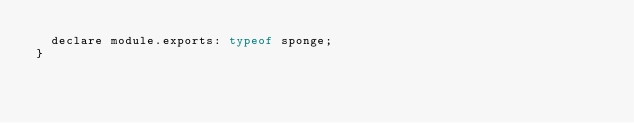<code> <loc_0><loc_0><loc_500><loc_500><_JavaScript_>  declare module.exports: typeof sponge;
}
</code> 